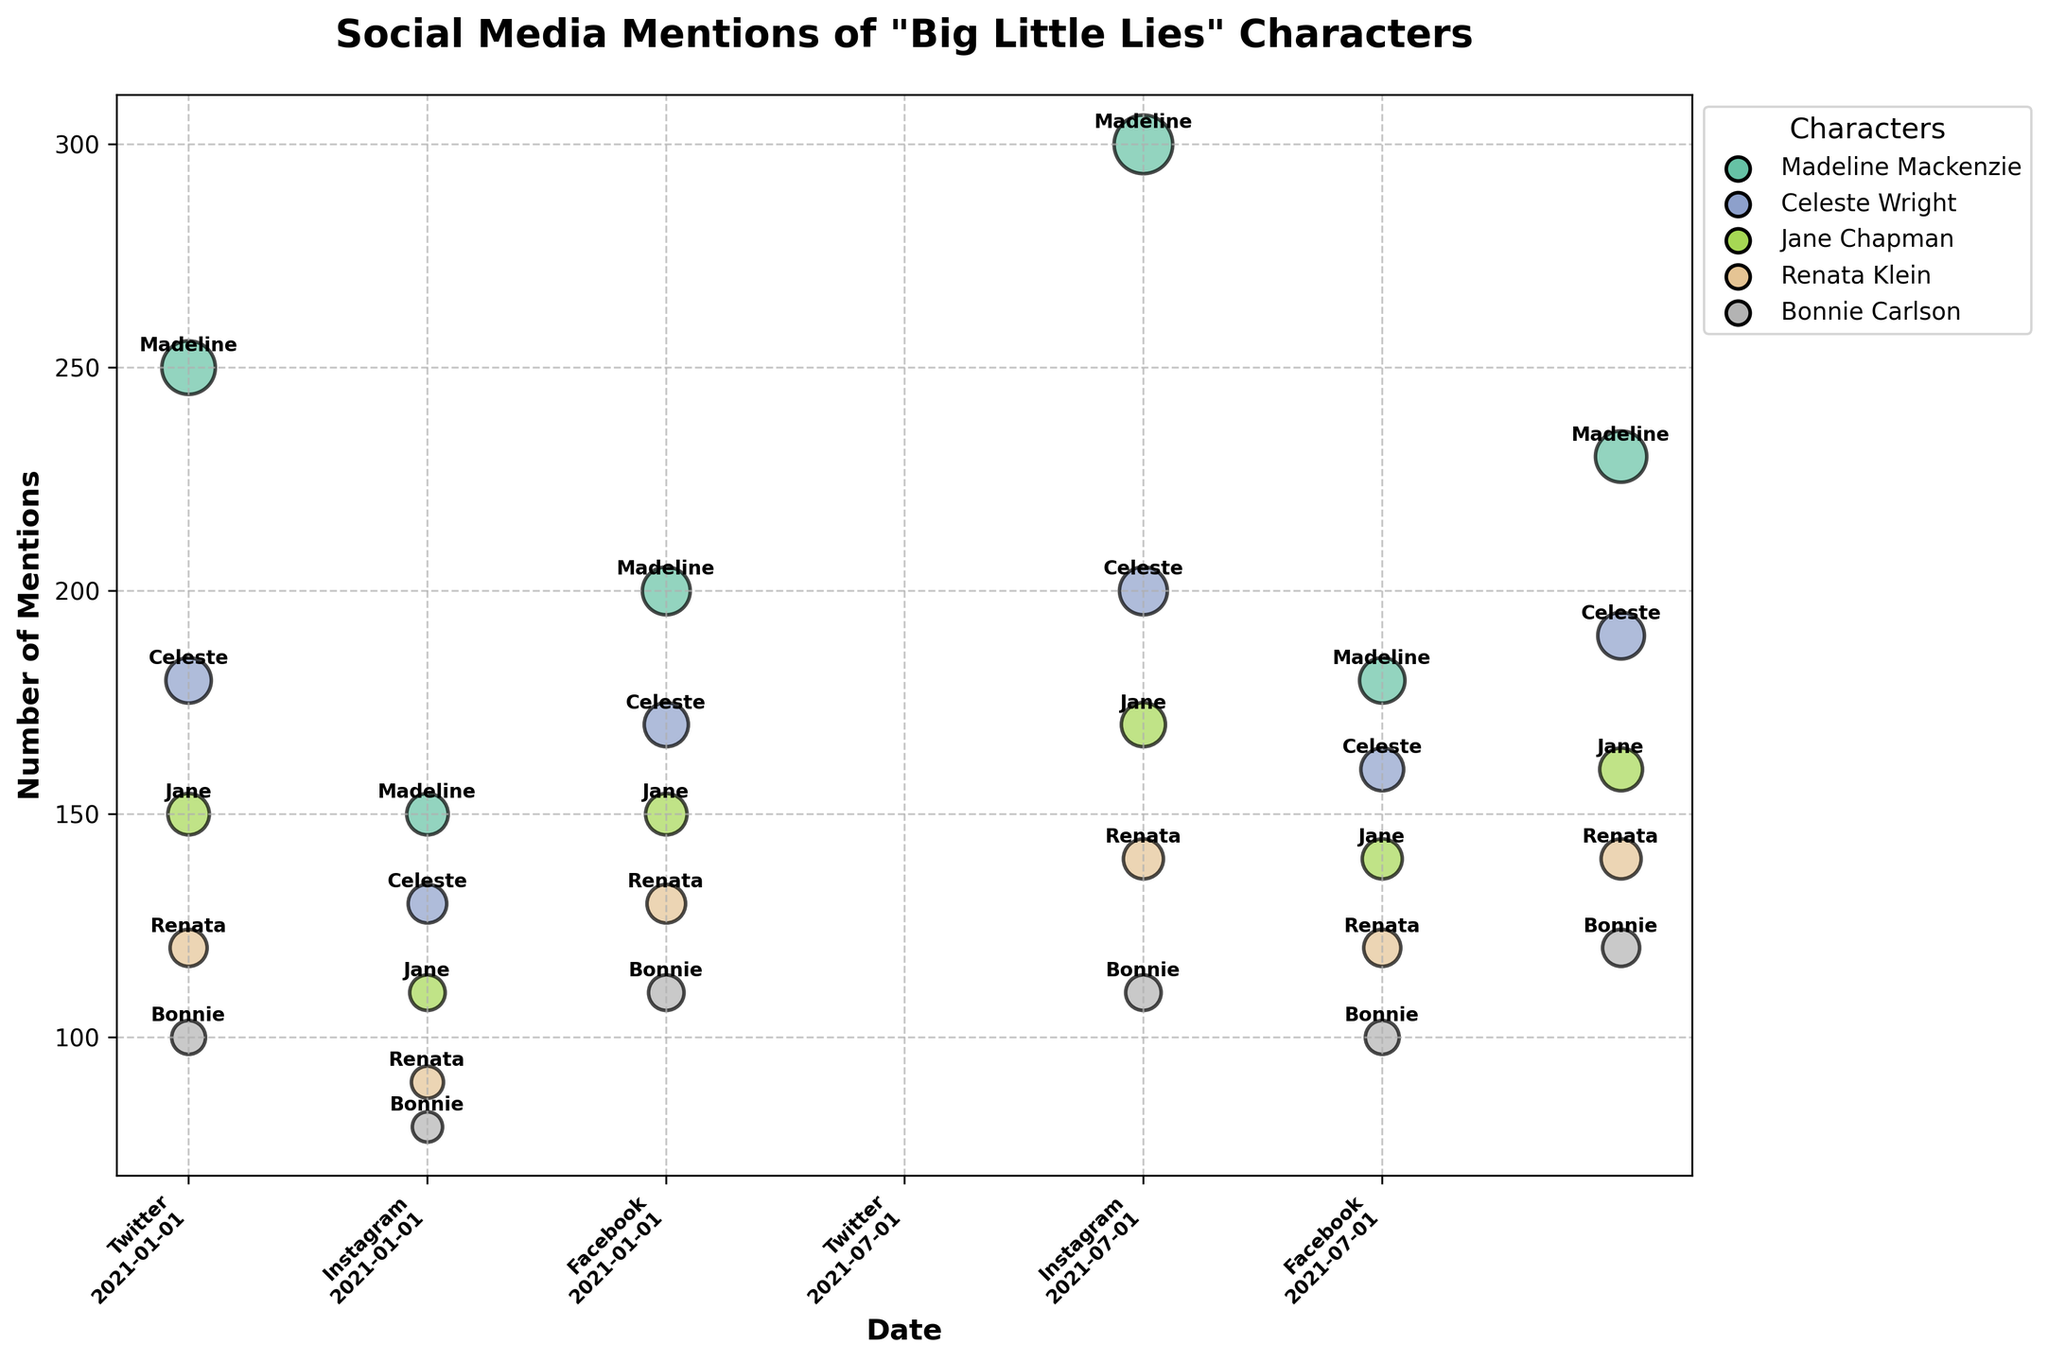Which character had the most mentions in July 2021 on Twitter? To determine this, look at the size of the bubbles for July 2021 under the Twitter platform. The largest bubble corresponds to Madeline Mackenzie with 300 mentions.
Answer: Madeline Mackenzie How many mentions did Celeste Wright receive on Instagram in January 2021? Locate the Instagram section for January 2021 and find the bubble associated with Celeste Wright. The mentioned count is detailed in the figure's label or bubble annotation.
Answer: 130 Which character had an increase in mentions on Facebook from January to July 2021? Compare the Facebook bubbles for each character between January and July 2021. All characters had increased mentions, but Madeline Mackenzie went from 200 to 230 mentions.
Answer: Madeline Mackenzie What is the difference in the number of mentions of Renata Klein on Facebook between January and July 2021? Subtract the number of mentions in January (130) from the number of mentions in July (140).
Answer: 10 Which platform showed the highest number of mentions for Jane Chapman in July 2021? Examine the size of Jane Chapman's bubbles across all platforms for July 2021 and find Facebook with 160 mentions as the largest.
Answer: Facebook Compare the total mentions for Bonnie Carlson across all platforms in January 2021. Sum up the mentions on Twitter, Instagram, and Facebook for Bonnie Carlson in January 2021 (100 + 80 + 110).
Answer: 290 How does the number of mentions for Madeline Mackenzie on Instagram in July 2021 compare to her mentions on Twitter in the same month? Madeline Mackenzie had 180 mentions on Instagram and 300 mentions on Twitter in July 2021. Comparing these values, the Twitter mentions are higher.
Answer: Twitter mentions are higher What is the average number of mentions for Celeste Wright on all social media platforms in January 2021? Average the mentions from Twitter (180), Instagram (130), and Facebook (170). The average is (180 + 130 + 170) / 3 = 160.
Answer: 160 Which character received the least mentions on Twitter in January 2021? Look at the Twitter section for January 2021. Bonnie Carlson has the smallest bubble with 100 mentions.
Answer: Bonnie Carlson 